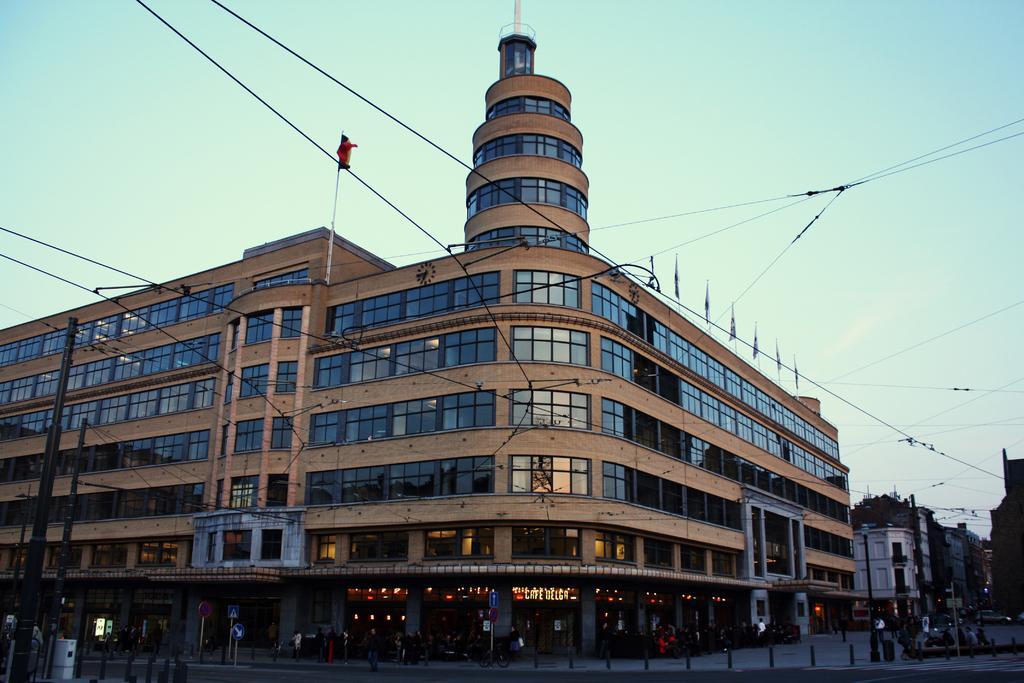Please provide a concise description of this image. In the image there is a huge building and there are some wires attached to the building, there are caution boards, pavement and few people in front of the building. 